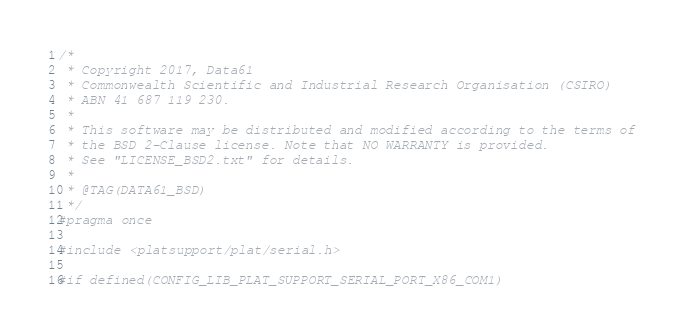Convert code to text. <code><loc_0><loc_0><loc_500><loc_500><_C_>/*
 * Copyright 2017, Data61
 * Commonwealth Scientific and Industrial Research Organisation (CSIRO)
 * ABN 41 687 119 230.
 *
 * This software may be distributed and modified according to the terms of
 * the BSD 2-Clause license. Note that NO WARRANTY is provided.
 * See "LICENSE_BSD2.txt" for details.
 *
 * @TAG(DATA61_BSD)
 */
#pragma once

#include <platsupport/plat/serial.h>

#if defined(CONFIG_LIB_PLAT_SUPPORT_SERIAL_PORT_X86_COM1)</code> 